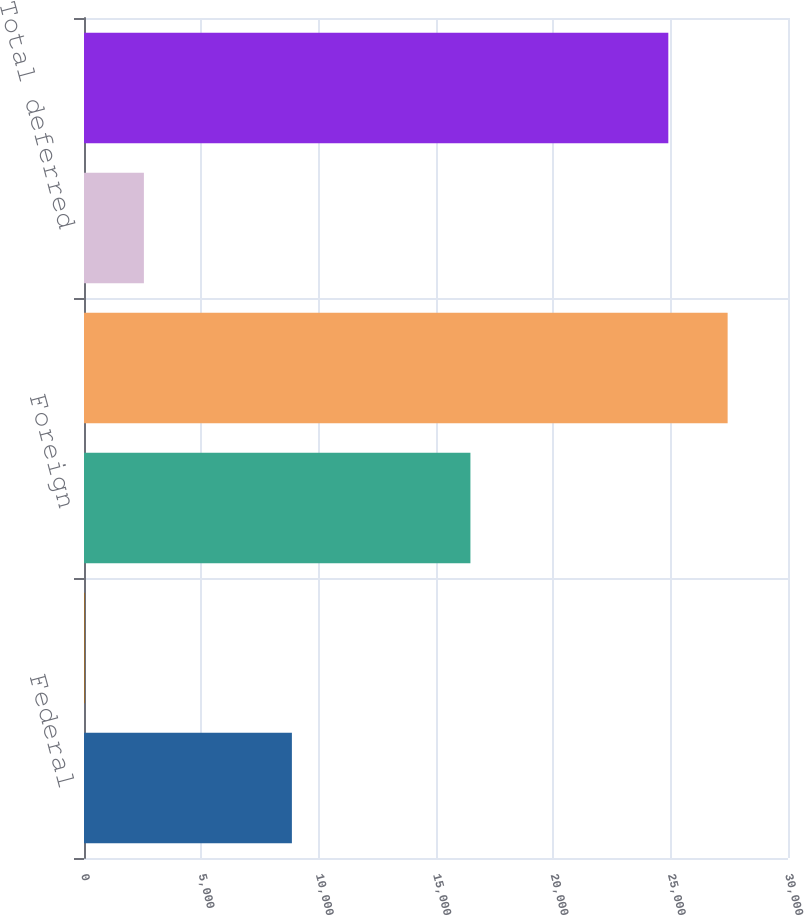<chart> <loc_0><loc_0><loc_500><loc_500><bar_chart><fcel>Federal<fcel>State<fcel>Foreign<fcel>Total current<fcel>Total deferred<fcel>Provision for income taxes<nl><fcel>8859<fcel>25<fcel>16467<fcel>27427.6<fcel>2552.6<fcel>24900<nl></chart> 